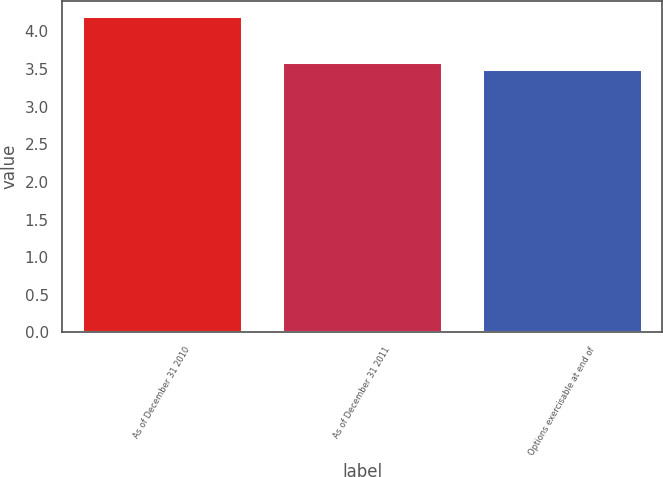Convert chart to OTSL. <chart><loc_0><loc_0><loc_500><loc_500><bar_chart><fcel>As of December 31 2010<fcel>As of December 31 2011<fcel>Options exercisable at end of<nl><fcel>4.2<fcel>3.6<fcel>3.5<nl></chart> 